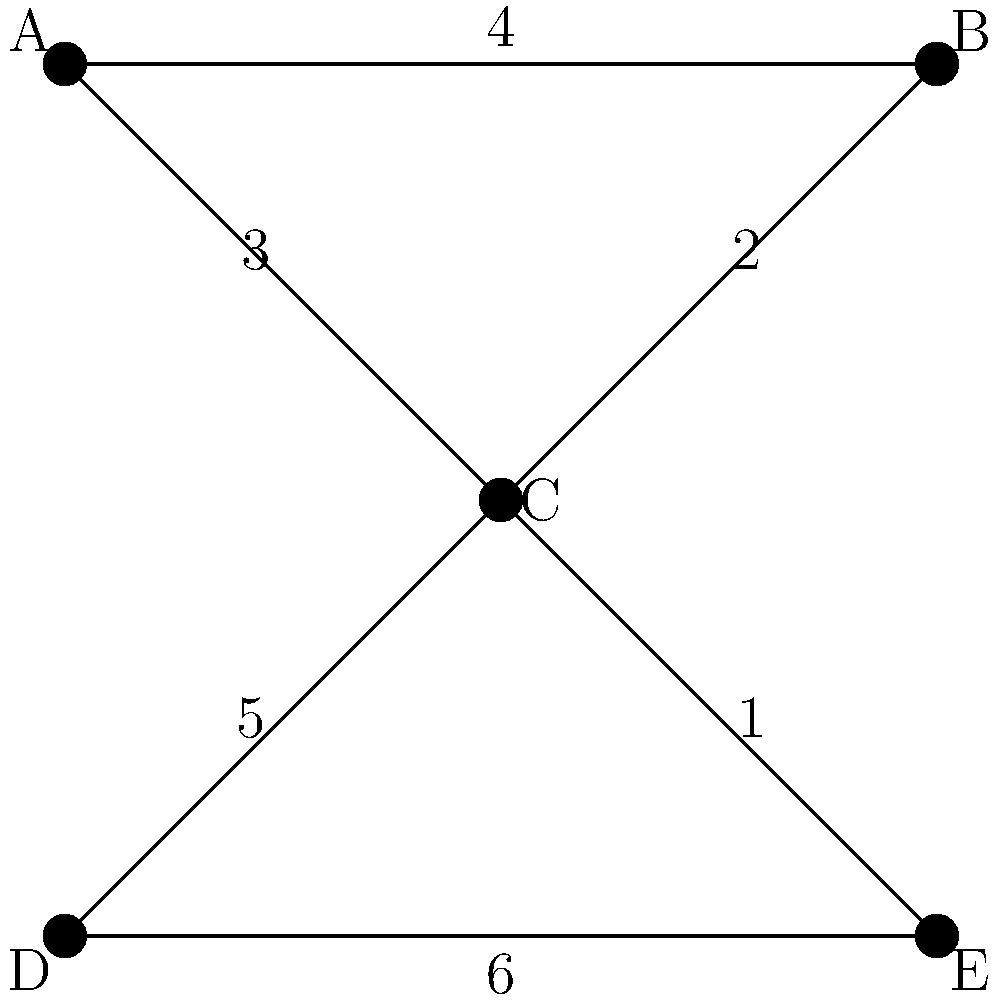In the network of key decision-makers in energy policy shown above, vertices represent influential individuals, and edge weights represent the strength of connections (lower values indicate stronger connections). What is the shortest path from decision-maker A to decision-maker E, and what is its total weight? To find the shortest path from A to E, we need to consider all possible paths and their total weights:

1. Path A-B-C-E:
   Weight = 4 + 2 + 1 = 7

2. Path A-C-E:
   Weight = 3 + 1 = 4

3. Path A-C-D-E:
   Weight = 3 + 5 + 6 = 14

4. Path A-B-C-D-E:
   Weight = 4 + 2 + 5 + 6 = 17

The shortest path is the one with the lowest total weight. In this case, it's path A-C-E with a total weight of 4.

This path represents the most efficient way to connect with decision-maker E starting from A, utilizing the strongest connections (lowest edge weights) in the network.
Answer: A-C-E, 4 